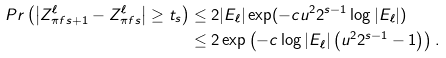<formula> <loc_0><loc_0><loc_500><loc_500>P r \left ( \left | Z ^ { \ell } _ { \pi f { s + 1 } } - Z ^ { \ell } _ { \pi f { s } } \right | \geq t _ { s } \right ) & \leq 2 | E _ { \ell } | \exp ( - c u ^ { 2 } 2 ^ { s - 1 } \log | E _ { \ell } | ) \\ & \leq 2 \exp \left ( - c \log | E _ { \ell } | \left ( u ^ { 2 } 2 ^ { s - 1 } - 1 \right ) \right ) .</formula> 